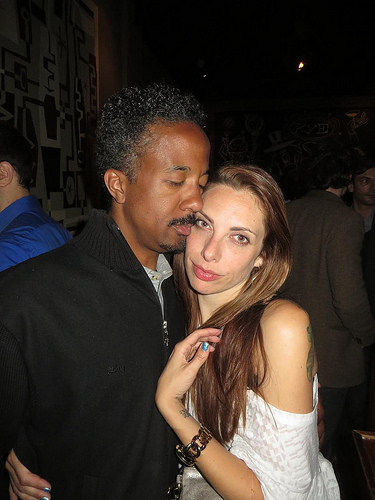<image>
Is the guy on the girl? No. The guy is not positioned on the girl. They may be near each other, but the guy is not supported by or resting on top of the girl. 